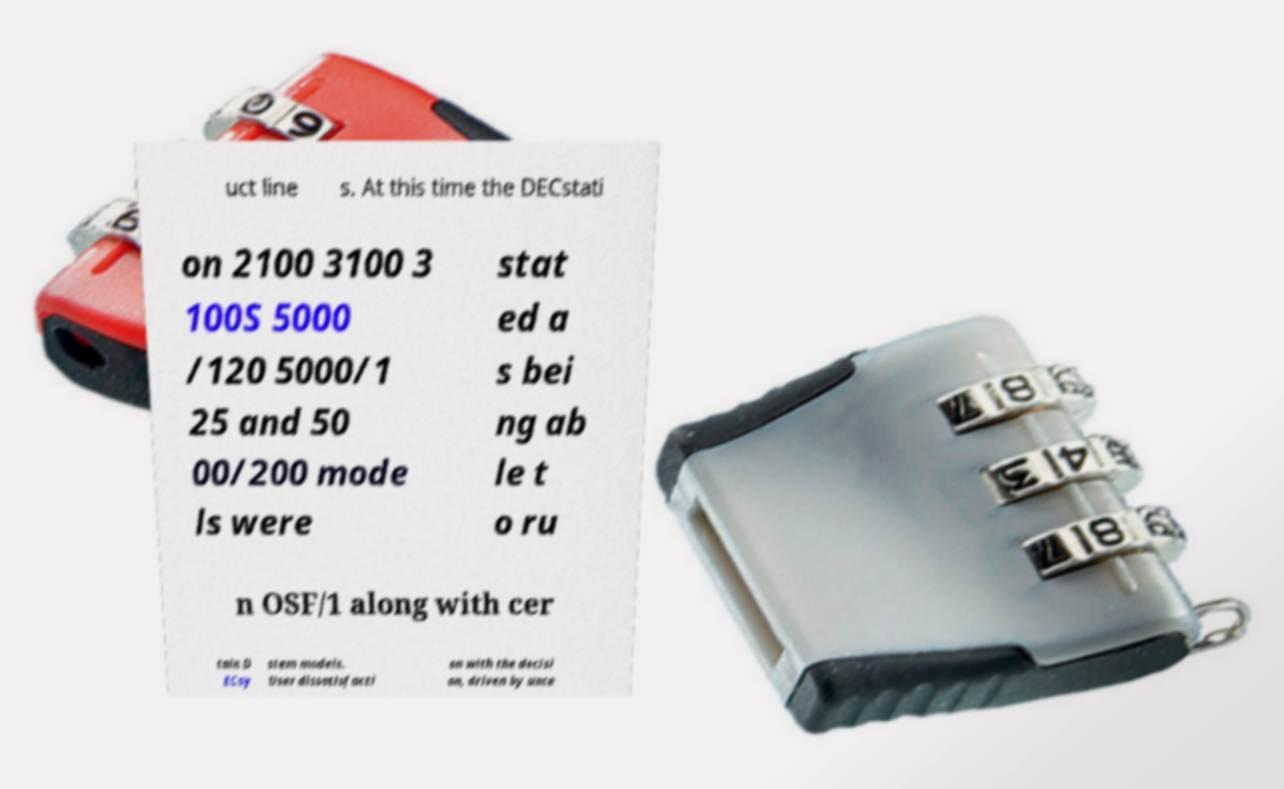Can you accurately transcribe the text from the provided image for me? uct line s. At this time the DECstati on 2100 3100 3 100S 5000 /120 5000/1 25 and 50 00/200 mode ls were stat ed a s bei ng ab le t o ru n OSF/1 along with cer tain D ECsy stem models. User dissatisfacti on with the decisi on, driven by unce 